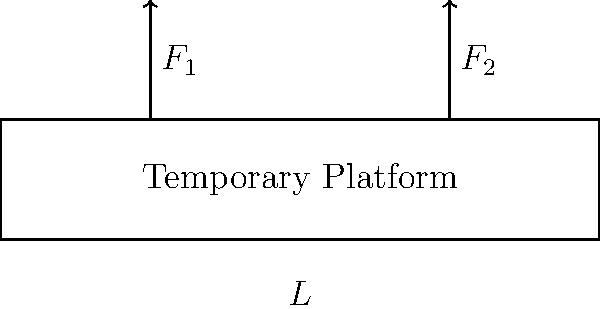A temporary platform needs to be set up for catering equipment on a film set. The platform is 5 meters long and supported at both ends. Two heavy pieces of equipment, each weighing 500 kg, need to be placed on the platform. The first piece (F₁) is located 1 meter from the left end, and the second piece (F₂) is located 1 meter from the right end. If the maximum allowable bending moment for the platform is 3000 N·m, determine if the platform can safely support the equipment. To determine if the platform can safely support the equipment, we need to calculate the maximum bending moment and compare it to the allowable limit. Let's follow these steps:

1. Convert weights to forces:
   $F_1 = F_2 = 500 \text{ kg} \times 9.81 \text{ m/s}^2 = 4905 \text{ N}$

2. Calculate reactions at supports:
   Due to symmetry, each support bears half the total load.
   $R_A = R_B = (4905 \text{ N} + 4905 \text{ N}) / 2 = 4905 \text{ N}$

3. Calculate maximum bending moment:
   The maximum bending moment occurs at the location of either load.
   $M_{max} = R_A \times 1 \text{ m} = 4905 \text{ N} \times 1 \text{ m} = 4905 \text{ N·m}$

4. Compare to allowable bending moment:
   Maximum bending moment: 4905 N·m
   Allowable bending moment: 3000 N·m

5. Conclusion:
   Since 4905 N·m > 3000 N·m, the platform cannot safely support the equipment as the maximum bending moment exceeds the allowable limit.
Answer: No, the platform cannot safely support the equipment. 